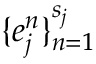Convert formula to latex. <formula><loc_0><loc_0><loc_500><loc_500>\{ e _ { j } ^ { n } \} _ { n = 1 } ^ { s _ { j } }</formula> 